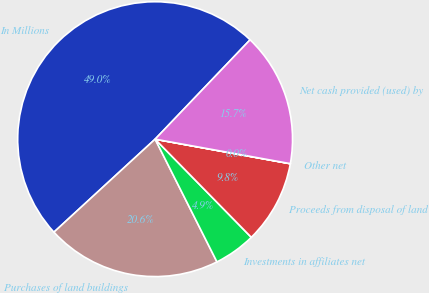Convert chart to OTSL. <chart><loc_0><loc_0><loc_500><loc_500><pie_chart><fcel>In Millions<fcel>Purchases of land buildings<fcel>Investments in affiliates net<fcel>Proceeds from disposal of land<fcel>Other net<fcel>Net cash provided (used) by<nl><fcel>48.97%<fcel>20.6%<fcel>4.91%<fcel>9.8%<fcel>0.01%<fcel>15.71%<nl></chart> 